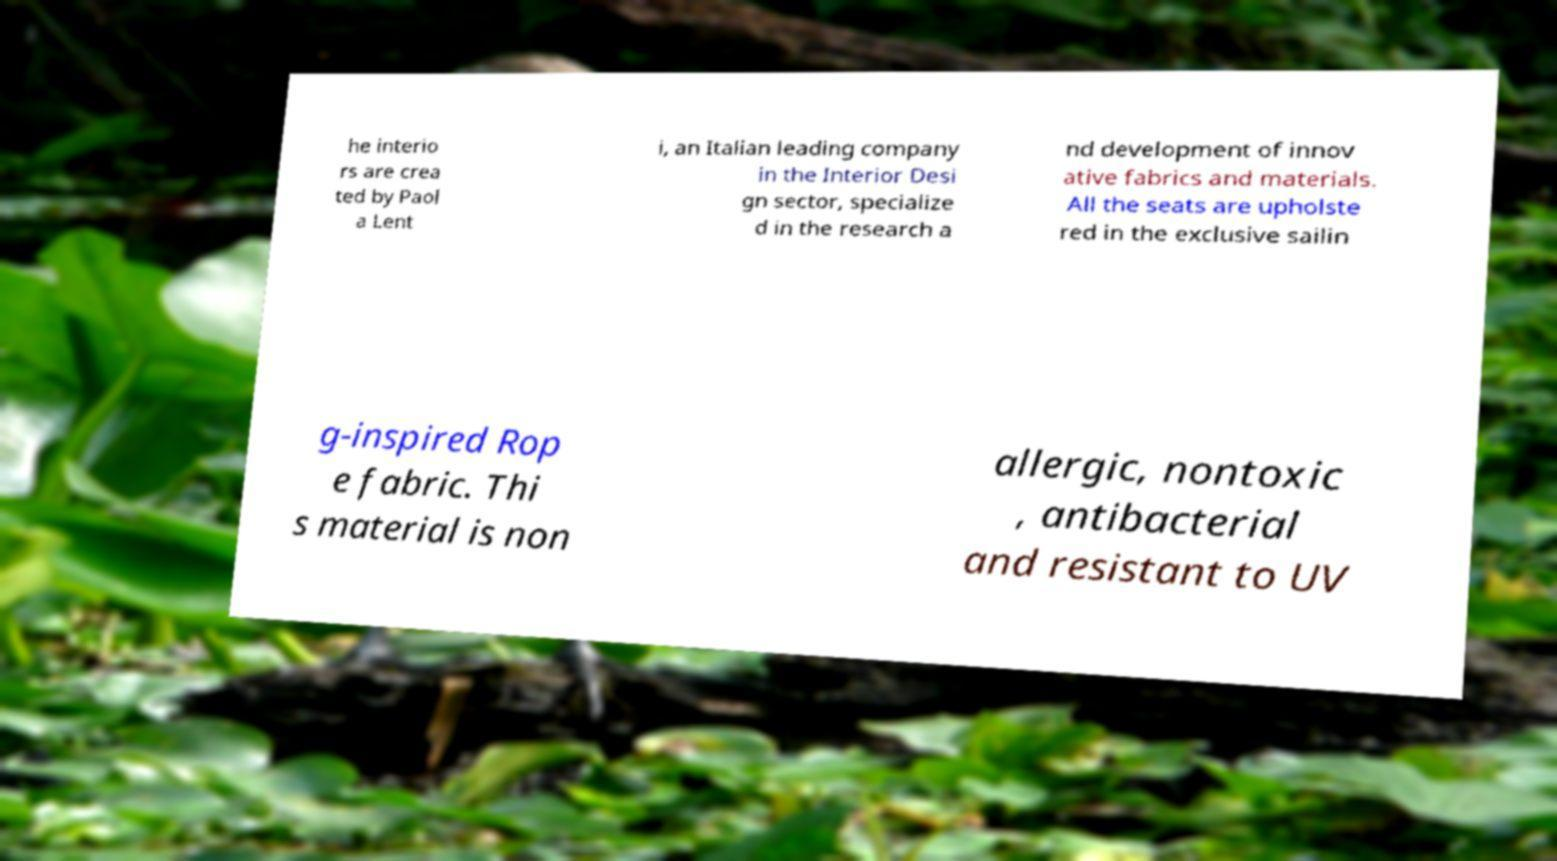For documentation purposes, I need the text within this image transcribed. Could you provide that? he interio rs are crea ted by Paol a Lent i, an Italian leading company in the Interior Desi gn sector, specialize d in the research a nd development of innov ative fabrics and materials. All the seats are upholste red in the exclusive sailin g-inspired Rop e fabric. Thi s material is non allergic, nontoxic , antibacterial and resistant to UV 